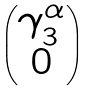Convert formula to latex. <formula><loc_0><loc_0><loc_500><loc_500>\begin{pmatrix} \gamma _ { 3 } ^ { \alpha } \\ 0 \end{pmatrix}</formula> 